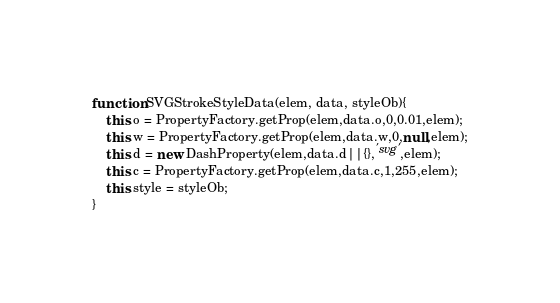Convert code to text. <code><loc_0><loc_0><loc_500><loc_500><_JavaScript_>function SVGStrokeStyleData(elem, data, styleOb){
	this.o = PropertyFactory.getProp(elem,data.o,0,0.01,elem);
	this.w = PropertyFactory.getProp(elem,data.w,0,null,elem);
	this.d = new DashProperty(elem,data.d||{},'svg',elem);
	this.c = PropertyFactory.getProp(elem,data.c,1,255,elem);
	this.style = styleOb;
}</code> 